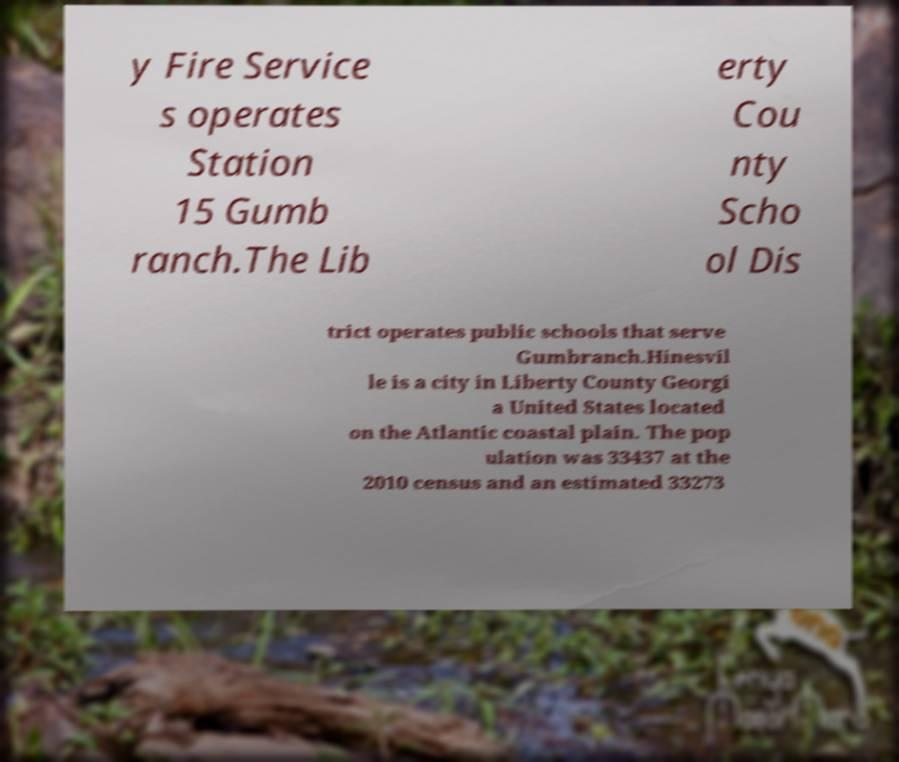There's text embedded in this image that I need extracted. Can you transcribe it verbatim? y Fire Service s operates Station 15 Gumb ranch.The Lib erty Cou nty Scho ol Dis trict operates public schools that serve Gumbranch.Hinesvil le is a city in Liberty County Georgi a United States located on the Atlantic coastal plain. The pop ulation was 33437 at the 2010 census and an estimated 33273 